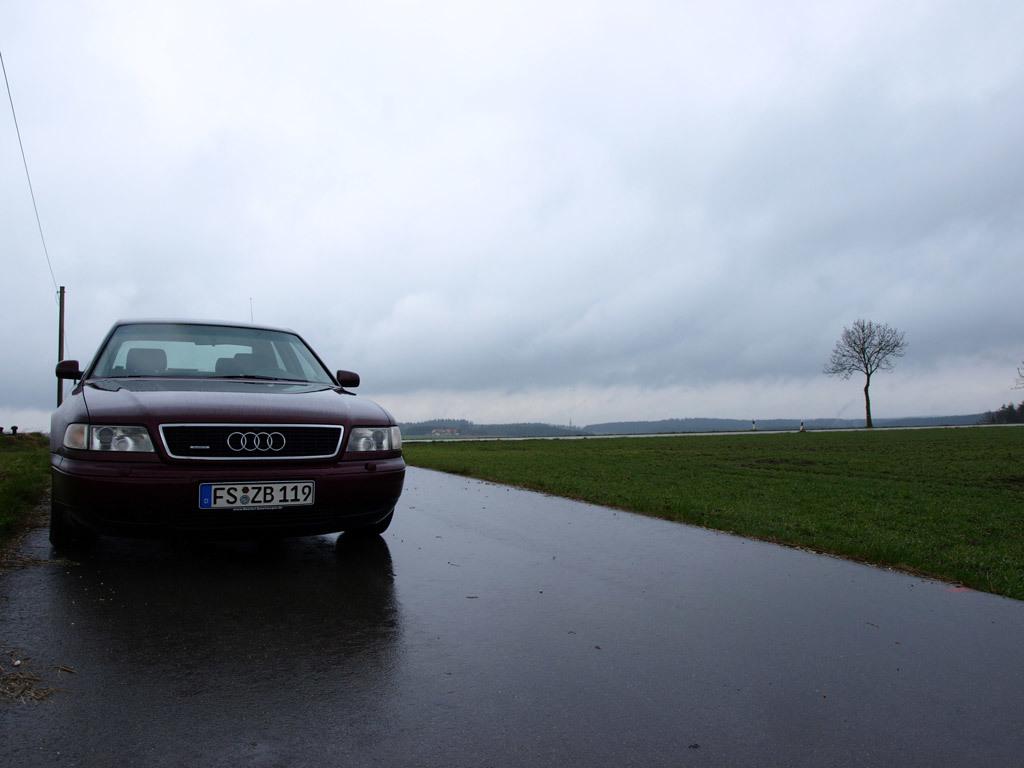What is the license plate number?
Offer a terse response. Fszb119. 